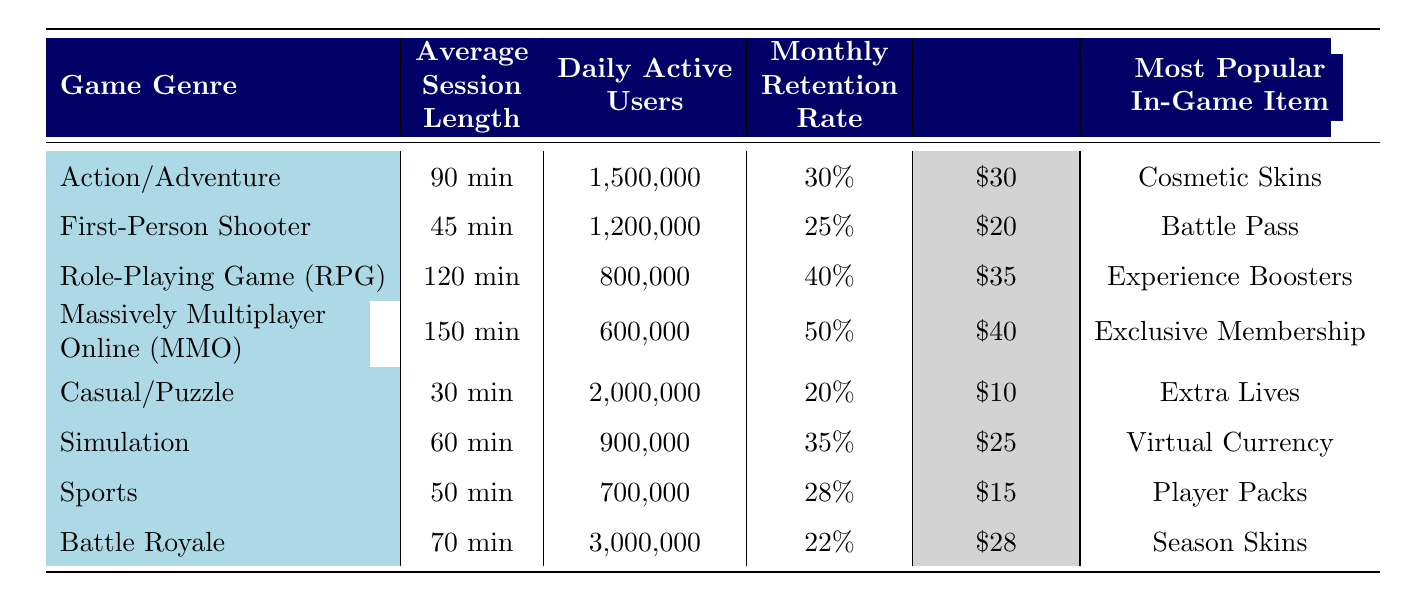What is the Average Session Length for Casual/Puzzle games? By directly scanning the row for Casual/Puzzle, the Average Session Length is listed as 30 minutes in the table.
Answer: 30 minutes Which game genre has the highest Monthly Retention Rate? The table shows the Monthly Retention Rates for all genres. The Max value can be found by comparing the percentages, where 'Massively Multiplayer Online (MMO)' has 50%, the highest among them.
Answer: Massively Multiplayer Online (MMO) How many Daily Active Users does the Action/Adventure genre have compared to Sports? Daily Active Users for Action/Adventure is 1,500,000, and for Sports, it is 700,000. To compare, just subtract 700,000 from 1,500,000, resulting in 800,000 more Daily Active Users for Action/Adventure.
Answer: 800,000 Is the Most Popular In-Game Item for First-Person Shooter the same as for Battle Royale? The Most Popular In-Game Item for First-Person Shooter is the 'Battle Pass,' while for Battle Royale, it is 'Season Skins.' Since they are different, the answer is no.
Answer: No What is the total average in-game purchases for Action/Adventure and Role-Playing Game (RPG) combined? To find the total, add the Average In-Game Purchases of Action/Adventure ($30) and RPG ($35) together, resulting in a total of $65.
Answer: $65 How does the Average Session Length of Simulation games compare to Battle Royale games? The Average Session Length for Simulation is 60 minutes, while for Battle Royale, it is 70 minutes. Since 60 minutes is less than 70 minutes, we find that Simulation games have a shorter session length.
Answer: Shorter Which genre has a lower Daily Active User count, MMORPG or RPG? The table shows that Massively Multiplayer Online (MMO) has 600,000 Daily Active Users and Role-Playing Game (RPG) has 800,000. By comparing these values, MMORPG has a lower count.
Answer: Massively Multiplayer Online (MMO) What is the average Daily Active Users for genres with an Average Session Length greater than 60 minutes? The genres with an Average Session Length greater than 60 minutes are RPG (800,000), MMO (600,000), and Action/Adventure (1,500,000). To find the average: add these counts (800,000 + 600,000 + 1,500,000 = 2,900,000) and divide by 3, resulting in approximately 966,667.
Answer: 966,667 What is the Most Popular In-Game Item across all genres? Analyzing the Most Popular Items for each genre, we can observe that there is no single item that appears across all genres. Each has a unique item, so the answer is that there is no most popular item across all genres.
Answer: No single item 